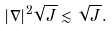Convert formula to latex. <formula><loc_0><loc_0><loc_500><loc_500>| \nabla | ^ { 2 } \sqrt { J } \lesssim \sqrt { J } .</formula> 